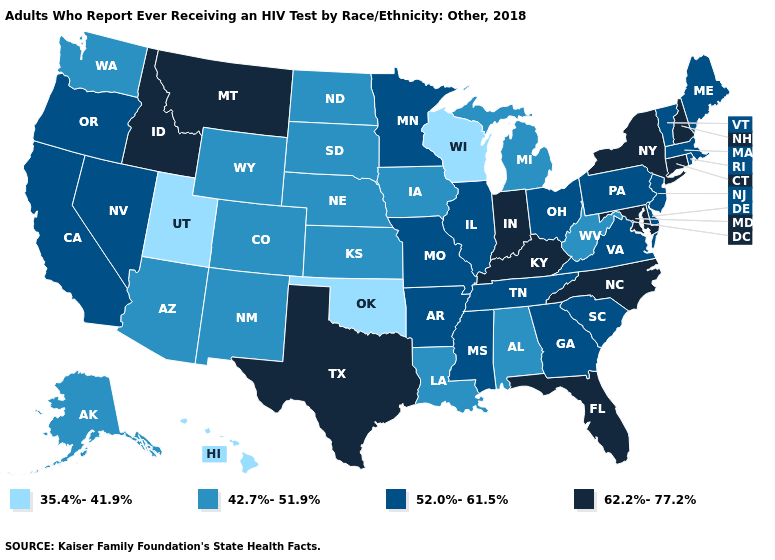Does Nevada have a higher value than Colorado?
Quick response, please. Yes. What is the value of Louisiana?
Write a very short answer. 42.7%-51.9%. What is the lowest value in states that border Florida?
Short answer required. 42.7%-51.9%. Name the states that have a value in the range 42.7%-51.9%?
Answer briefly. Alabama, Alaska, Arizona, Colorado, Iowa, Kansas, Louisiana, Michigan, Nebraska, New Mexico, North Dakota, South Dakota, Washington, West Virginia, Wyoming. Name the states that have a value in the range 62.2%-77.2%?
Short answer required. Connecticut, Florida, Idaho, Indiana, Kentucky, Maryland, Montana, New Hampshire, New York, North Carolina, Texas. Among the states that border Pennsylvania , does Ohio have the lowest value?
Short answer required. No. What is the value of North Dakota?
Give a very brief answer. 42.7%-51.9%. What is the highest value in the USA?
Concise answer only. 62.2%-77.2%. Name the states that have a value in the range 52.0%-61.5%?
Concise answer only. Arkansas, California, Delaware, Georgia, Illinois, Maine, Massachusetts, Minnesota, Mississippi, Missouri, Nevada, New Jersey, Ohio, Oregon, Pennsylvania, Rhode Island, South Carolina, Tennessee, Vermont, Virginia. Name the states that have a value in the range 52.0%-61.5%?
Short answer required. Arkansas, California, Delaware, Georgia, Illinois, Maine, Massachusetts, Minnesota, Mississippi, Missouri, Nevada, New Jersey, Ohio, Oregon, Pennsylvania, Rhode Island, South Carolina, Tennessee, Vermont, Virginia. Does the map have missing data?
Write a very short answer. No. Does California have a higher value than North Carolina?
Quick response, please. No. Among the states that border Vermont , does Massachusetts have the lowest value?
Short answer required. Yes. Does the first symbol in the legend represent the smallest category?
Concise answer only. Yes. 